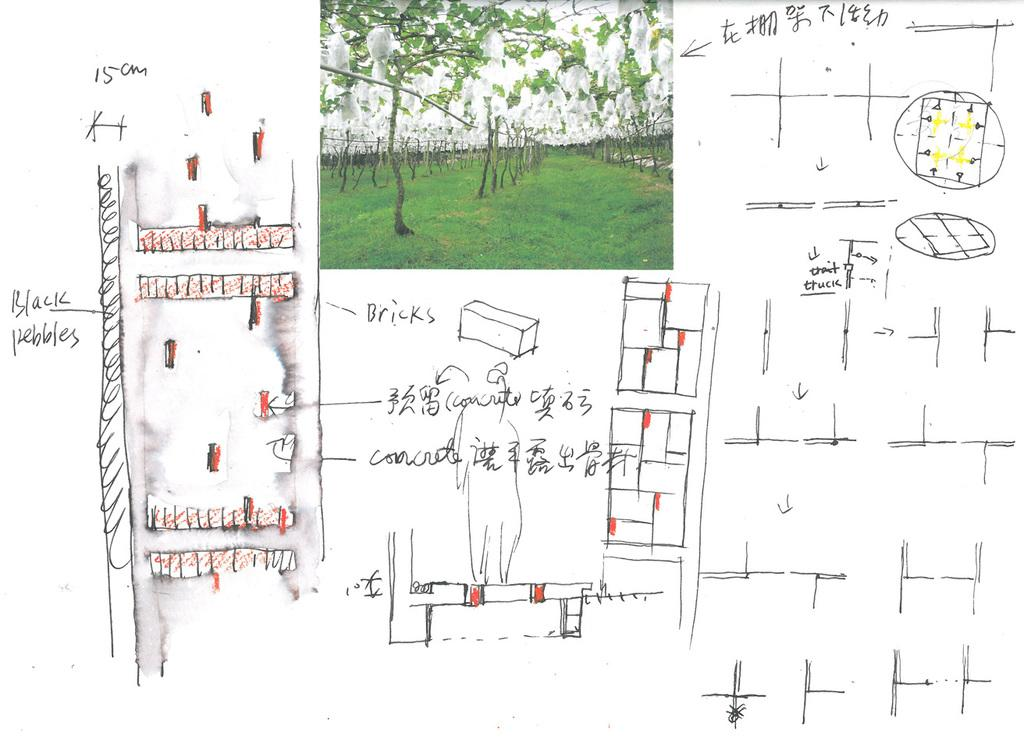What type of vegetation can be seen in the image? There is grass in the image. Are there any other plants visible in the image? Yes, there are trees in the image. What part of the natural environment is visible in the image? The sky is visible in the image. What is written in the image? There is some matter written in the image. Can you see any holes in the grass in the image? There are no holes visible in the grass in the image. What type of needle is being used to sew the trees in the image? There is no needle or sewing activity present in the image; it features grass, trees, and the sky. 